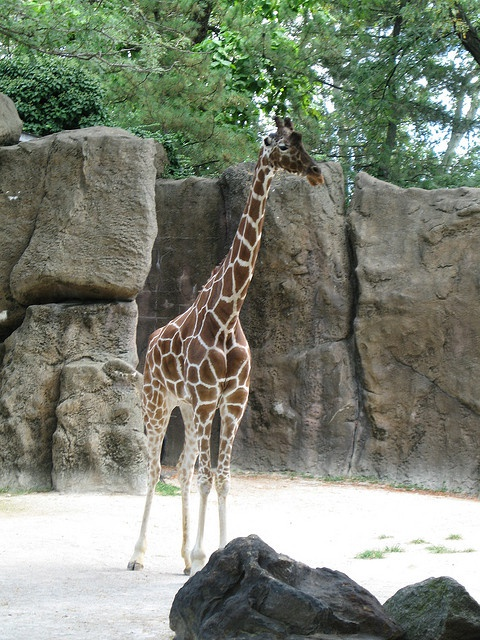Describe the objects in this image and their specific colors. I can see a giraffe in teal, darkgray, lightgray, gray, and maroon tones in this image. 